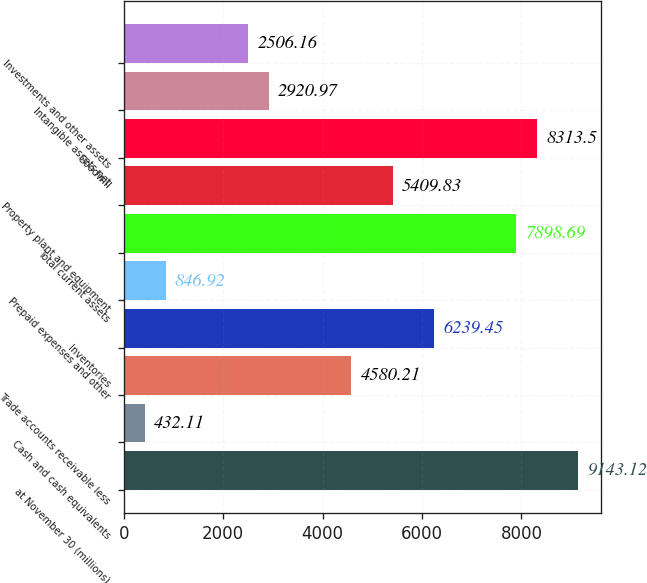<chart> <loc_0><loc_0><loc_500><loc_500><bar_chart><fcel>at November 30 (millions)<fcel>Cash and cash equivalents<fcel>Trade accounts receivable less<fcel>Inventories<fcel>Prepaid expenses and other<fcel>Total current assets<fcel>Property plant and equipment<fcel>Goodwill<fcel>Intangible assets net<fcel>Investments and other assets<nl><fcel>9143.12<fcel>432.11<fcel>4580.21<fcel>6239.45<fcel>846.92<fcel>7898.69<fcel>5409.83<fcel>8313.5<fcel>2920.97<fcel>2506.16<nl></chart> 